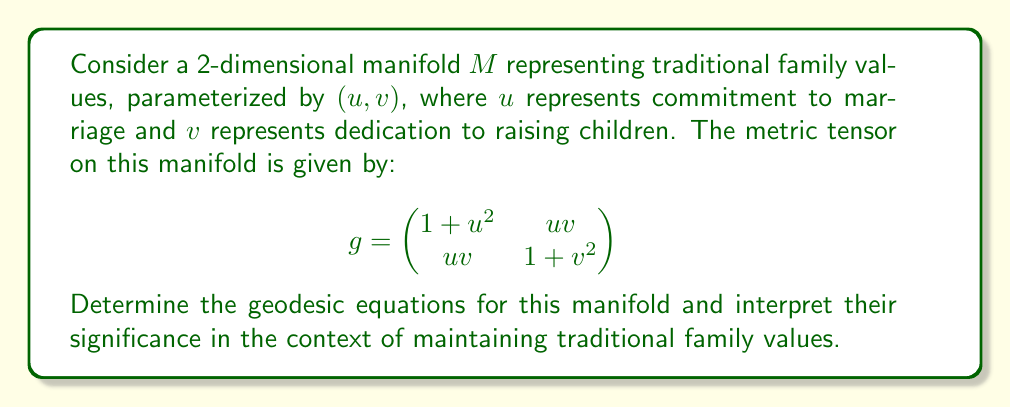Teach me how to tackle this problem. To find the geodesic equations, we need to follow these steps:

1) Calculate the Christoffel symbols $\Gamma^i_{jk}$ using the formula:

   $$\Gamma^i_{jk} = \frac{1}{2}g^{im}(\partial_j g_{mk} + \partial_k g_{mj} - \partial_m g_{jk})$$

2) The inverse metric tensor $g^{-1}$ is:

   $$g^{-1} = \frac{1}{(1+u^2)(1+v^2)-u^2v^2}\begin{pmatrix}
   1+v^2 & -uv \\
   -uv & 1+u^2
   \end{pmatrix}$$

3) Calculating the Christoffel symbols:

   $\Gamma^1_{11} = \frac{u(1+v^2)}{(1+u^2)(1+v^2)-u^2v^2}$
   
   $\Gamma^1_{12} = \Gamma^1_{21} = \frac{v(1+v^2)}{(1+u^2)(1+v^2)-u^2v^2}$
   
   $\Gamma^1_{22} = -\frac{uv^2}{(1+u^2)(1+v^2)-u^2v^2}$
   
   $\Gamma^2_{11} = -\frac{u^2v}{(1+u^2)(1+v^2)-u^2v^2}$
   
   $\Gamma^2_{12} = \Gamma^2_{21} = \frac{u(1+u^2)}{(1+u^2)(1+v^2)-u^2v^2}$
   
   $\Gamma^2_{22} = \frac{v(1+u^2)}{(1+u^2)(1+v^2)-u^2v^2}$

4) The geodesic equations are:

   $$\frac{d^2u}{dt^2} + \Gamma^1_{11}(\frac{du}{dt})^2 + 2\Gamma^1_{12}\frac{du}{dt}\frac{dv}{dt} + \Gamma^1_{22}(\frac{dv}{dt})^2 = 0$$
   
   $$\frac{d^2v}{dt^2} + \Gamma^2_{11}(\frac{du}{dt})^2 + 2\Gamma^2_{12}\frac{du}{dt}\frac{dv}{dt} + \Gamma^2_{22}(\frac{dv}{dt})^2 = 0$$

Interpretation: These equations describe the optimal path (geodesic) in the space of traditional family values. The coupling between $u$ and $v$ in the equations suggests that commitment to marriage and dedication to raising children are interconnected in maintaining traditional family values. The nonlinear nature of the equations implies that the balance between these values may require adjustments over time to stay on the optimal path.
Answer: Geodesic equations:
$$\frac{d^2u}{dt^2} + \Gamma^1_{11}(\frac{du}{dt})^2 + 2\Gamma^1_{12}\frac{du}{dt}\frac{dv}{dt} + \Gamma^1_{22}(\frac{dv}{dt})^2 = 0$$
$$\frac{d^2v}{dt^2} + \Gamma^2_{11}(\frac{du}{dt})^2 + 2\Gamma^2_{12}\frac{du}{dt}\frac{dv}{dt} + \Gamma^2_{22}(\frac{dv}{dt})^2 = 0$$ 